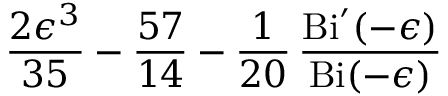Convert formula to latex. <formula><loc_0><loc_0><loc_500><loc_500>{ \frac { 2 \epsilon ^ { 3 } } { 3 5 } } - { \frac { 5 7 } { 1 4 } } - { \frac { 1 } { 2 0 } } \, { \frac { B i ^ { \prime } ( - \epsilon ) } { B i ( - \epsilon ) } }</formula> 